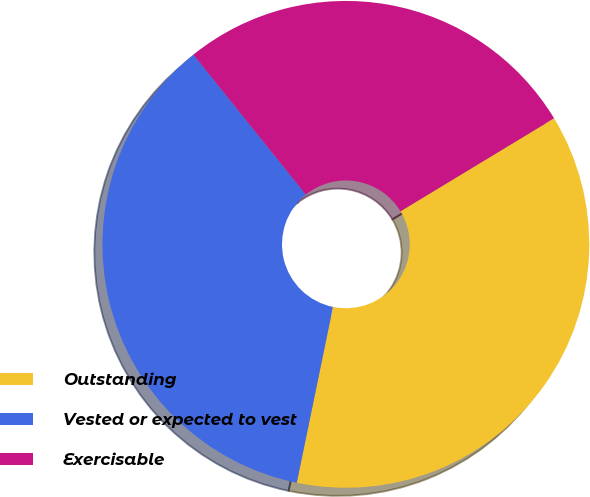Convert chart. <chart><loc_0><loc_0><loc_500><loc_500><pie_chart><fcel>Outstanding<fcel>Vested or expected to vest<fcel>Exercisable<nl><fcel>36.9%<fcel>36.0%<fcel>27.11%<nl></chart> 